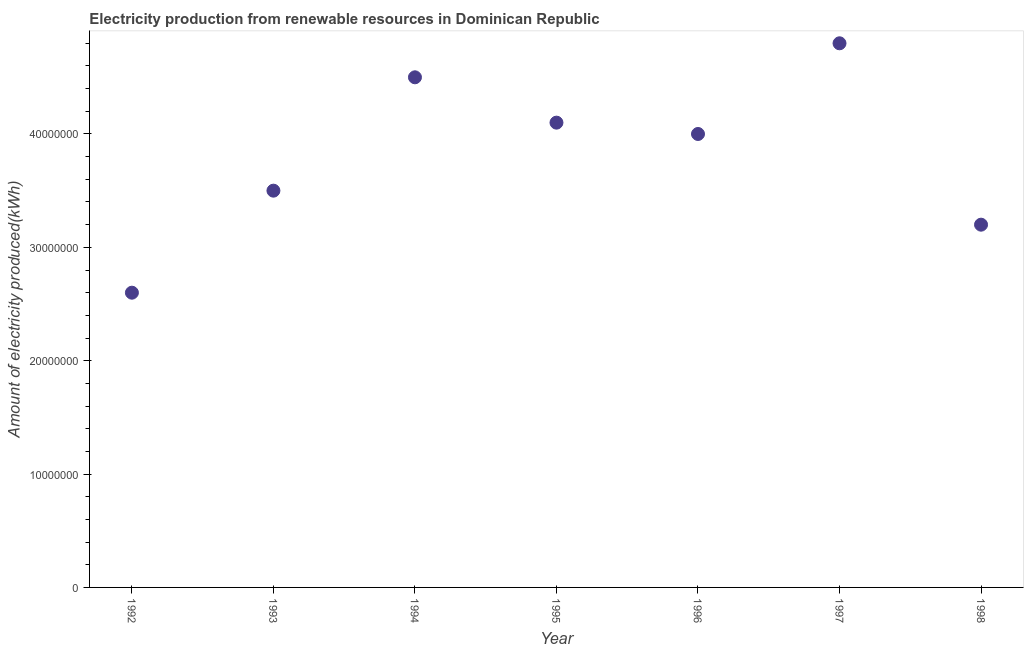What is the amount of electricity produced in 1997?
Offer a terse response. 4.80e+07. Across all years, what is the maximum amount of electricity produced?
Offer a terse response. 4.80e+07. Across all years, what is the minimum amount of electricity produced?
Give a very brief answer. 2.60e+07. In which year was the amount of electricity produced maximum?
Keep it short and to the point. 1997. What is the sum of the amount of electricity produced?
Provide a short and direct response. 2.67e+08. What is the difference between the amount of electricity produced in 1995 and 1998?
Provide a succinct answer. 9.00e+06. What is the average amount of electricity produced per year?
Ensure brevity in your answer.  3.81e+07. What is the median amount of electricity produced?
Your answer should be very brief. 4.00e+07. In how many years, is the amount of electricity produced greater than 44000000 kWh?
Give a very brief answer. 2. Do a majority of the years between 1997 and 1994 (inclusive) have amount of electricity produced greater than 40000000 kWh?
Provide a short and direct response. Yes. Is the difference between the amount of electricity produced in 1994 and 1995 greater than the difference between any two years?
Your answer should be compact. No. What is the difference between the highest and the second highest amount of electricity produced?
Your answer should be very brief. 3.00e+06. What is the difference between the highest and the lowest amount of electricity produced?
Make the answer very short. 2.20e+07. Does the amount of electricity produced monotonically increase over the years?
Your response must be concise. No. How many dotlines are there?
Your response must be concise. 1. How many years are there in the graph?
Make the answer very short. 7. What is the difference between two consecutive major ticks on the Y-axis?
Give a very brief answer. 1.00e+07. Does the graph contain any zero values?
Ensure brevity in your answer.  No. Does the graph contain grids?
Your response must be concise. No. What is the title of the graph?
Your response must be concise. Electricity production from renewable resources in Dominican Republic. What is the label or title of the Y-axis?
Offer a terse response. Amount of electricity produced(kWh). What is the Amount of electricity produced(kWh) in 1992?
Your answer should be very brief. 2.60e+07. What is the Amount of electricity produced(kWh) in 1993?
Ensure brevity in your answer.  3.50e+07. What is the Amount of electricity produced(kWh) in 1994?
Offer a terse response. 4.50e+07. What is the Amount of electricity produced(kWh) in 1995?
Offer a terse response. 4.10e+07. What is the Amount of electricity produced(kWh) in 1996?
Your answer should be compact. 4.00e+07. What is the Amount of electricity produced(kWh) in 1997?
Ensure brevity in your answer.  4.80e+07. What is the Amount of electricity produced(kWh) in 1998?
Your response must be concise. 3.20e+07. What is the difference between the Amount of electricity produced(kWh) in 1992 and 1993?
Ensure brevity in your answer.  -9.00e+06. What is the difference between the Amount of electricity produced(kWh) in 1992 and 1994?
Make the answer very short. -1.90e+07. What is the difference between the Amount of electricity produced(kWh) in 1992 and 1995?
Give a very brief answer. -1.50e+07. What is the difference between the Amount of electricity produced(kWh) in 1992 and 1996?
Give a very brief answer. -1.40e+07. What is the difference between the Amount of electricity produced(kWh) in 1992 and 1997?
Your answer should be very brief. -2.20e+07. What is the difference between the Amount of electricity produced(kWh) in 1992 and 1998?
Offer a very short reply. -6.00e+06. What is the difference between the Amount of electricity produced(kWh) in 1993 and 1994?
Your answer should be very brief. -1.00e+07. What is the difference between the Amount of electricity produced(kWh) in 1993 and 1995?
Provide a short and direct response. -6.00e+06. What is the difference between the Amount of electricity produced(kWh) in 1993 and 1996?
Your response must be concise. -5.00e+06. What is the difference between the Amount of electricity produced(kWh) in 1993 and 1997?
Make the answer very short. -1.30e+07. What is the difference between the Amount of electricity produced(kWh) in 1993 and 1998?
Provide a short and direct response. 3.00e+06. What is the difference between the Amount of electricity produced(kWh) in 1994 and 1995?
Ensure brevity in your answer.  4.00e+06. What is the difference between the Amount of electricity produced(kWh) in 1994 and 1997?
Make the answer very short. -3.00e+06. What is the difference between the Amount of electricity produced(kWh) in 1994 and 1998?
Your response must be concise. 1.30e+07. What is the difference between the Amount of electricity produced(kWh) in 1995 and 1996?
Provide a short and direct response. 1.00e+06. What is the difference between the Amount of electricity produced(kWh) in 1995 and 1997?
Offer a very short reply. -7.00e+06. What is the difference between the Amount of electricity produced(kWh) in 1995 and 1998?
Your answer should be very brief. 9.00e+06. What is the difference between the Amount of electricity produced(kWh) in 1996 and 1997?
Provide a short and direct response. -8.00e+06. What is the difference between the Amount of electricity produced(kWh) in 1996 and 1998?
Your answer should be compact. 8.00e+06. What is the difference between the Amount of electricity produced(kWh) in 1997 and 1998?
Provide a short and direct response. 1.60e+07. What is the ratio of the Amount of electricity produced(kWh) in 1992 to that in 1993?
Offer a very short reply. 0.74. What is the ratio of the Amount of electricity produced(kWh) in 1992 to that in 1994?
Your answer should be very brief. 0.58. What is the ratio of the Amount of electricity produced(kWh) in 1992 to that in 1995?
Your answer should be very brief. 0.63. What is the ratio of the Amount of electricity produced(kWh) in 1992 to that in 1996?
Keep it short and to the point. 0.65. What is the ratio of the Amount of electricity produced(kWh) in 1992 to that in 1997?
Offer a very short reply. 0.54. What is the ratio of the Amount of electricity produced(kWh) in 1992 to that in 1998?
Ensure brevity in your answer.  0.81. What is the ratio of the Amount of electricity produced(kWh) in 1993 to that in 1994?
Offer a very short reply. 0.78. What is the ratio of the Amount of electricity produced(kWh) in 1993 to that in 1995?
Your answer should be compact. 0.85. What is the ratio of the Amount of electricity produced(kWh) in 1993 to that in 1996?
Your response must be concise. 0.88. What is the ratio of the Amount of electricity produced(kWh) in 1993 to that in 1997?
Provide a succinct answer. 0.73. What is the ratio of the Amount of electricity produced(kWh) in 1993 to that in 1998?
Provide a succinct answer. 1.09. What is the ratio of the Amount of electricity produced(kWh) in 1994 to that in 1995?
Make the answer very short. 1.1. What is the ratio of the Amount of electricity produced(kWh) in 1994 to that in 1996?
Provide a succinct answer. 1.12. What is the ratio of the Amount of electricity produced(kWh) in 1994 to that in 1997?
Ensure brevity in your answer.  0.94. What is the ratio of the Amount of electricity produced(kWh) in 1994 to that in 1998?
Ensure brevity in your answer.  1.41. What is the ratio of the Amount of electricity produced(kWh) in 1995 to that in 1996?
Provide a succinct answer. 1.02. What is the ratio of the Amount of electricity produced(kWh) in 1995 to that in 1997?
Offer a very short reply. 0.85. What is the ratio of the Amount of electricity produced(kWh) in 1995 to that in 1998?
Offer a very short reply. 1.28. What is the ratio of the Amount of electricity produced(kWh) in 1996 to that in 1997?
Your answer should be compact. 0.83. What is the ratio of the Amount of electricity produced(kWh) in 1997 to that in 1998?
Offer a very short reply. 1.5. 